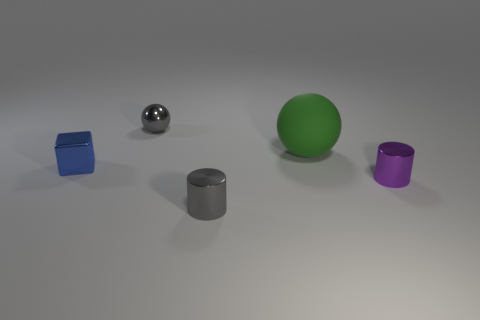There is a purple object; what shape is it?
Provide a short and direct response. Cylinder. Are any tiny cyan cylinders visible?
Give a very brief answer. No. Is the blue metal object the same shape as the big green object?
Offer a terse response. No. What number of large things are either blue things or cylinders?
Make the answer very short. 0. What is the color of the large rubber ball?
Your response must be concise. Green. There is a gray thing that is behind the metal cylinder that is to the left of the small purple thing; what shape is it?
Give a very brief answer. Sphere. Are there any cyan blocks that have the same material as the small purple cylinder?
Give a very brief answer. No. There is a metal thing that is behind the blue block; is it the same size as the big matte thing?
Provide a short and direct response. No. What number of gray things are metallic cubes or small metallic cylinders?
Your answer should be compact. 1. What is the gray thing behind the small block made of?
Your answer should be very brief. Metal. 